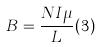<formula> <loc_0><loc_0><loc_500><loc_500>B = \frac { N I \mu } { L } ( 3 )</formula> 